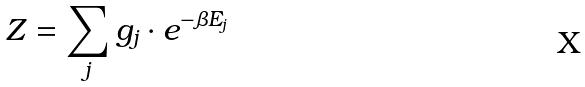<formula> <loc_0><loc_0><loc_500><loc_500>Z = \sum _ { j } g _ { j } \cdot e ^ { - \beta E _ { j } }</formula> 